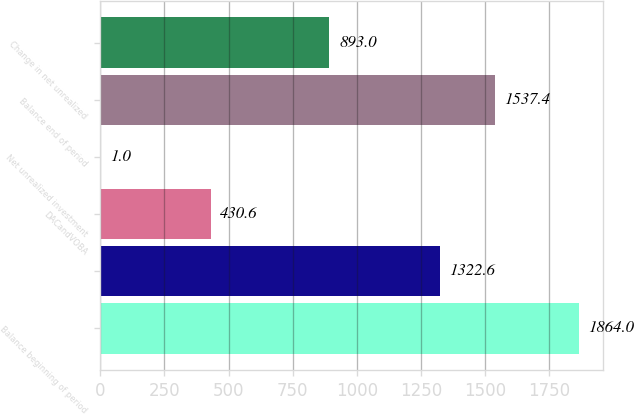<chart> <loc_0><loc_0><loc_500><loc_500><bar_chart><fcel>Balance beginning of period<fcel>Unnamed: 1<fcel>DACandVOBA<fcel>Net unrealized investment<fcel>Balance end of period<fcel>Change in net unrealized<nl><fcel>1864<fcel>1322.6<fcel>430.6<fcel>1<fcel>1537.4<fcel>893<nl></chart> 